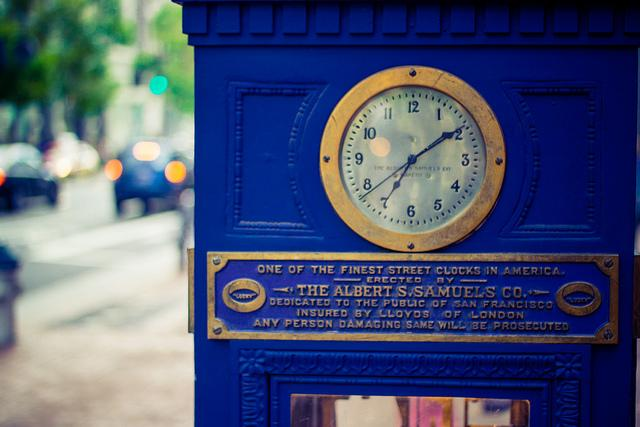In which metropolitan area is this clock installed? Please explain your reasoning. san francisco. There are two cities listed on the clock, but lloyds of london is the name of the company that insures the clock and not the location of the clock. 